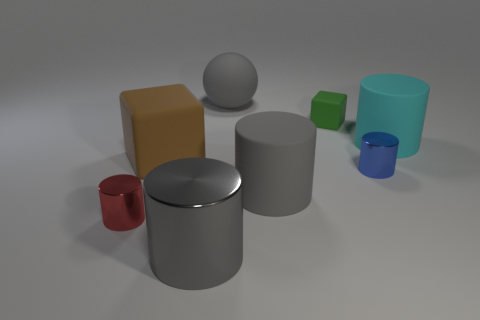Do the large ball and the large shiny cylinder have the same color?
Provide a succinct answer. Yes. There is a big thing that is behind the matte cylinder behind the block to the left of the large metallic cylinder; what is its shape?
Offer a terse response. Sphere. How big is the gray thing that is on the right side of the big ball?
Make the answer very short. Large. There is a blue metallic object that is the same size as the red cylinder; what shape is it?
Provide a succinct answer. Cylinder. What number of objects are tiny red metal cylinders or matte blocks behind the big brown thing?
Offer a very short reply. 2. There is a gray object behind the large cylinder that is behind the large brown block; what number of gray shiny cylinders are in front of it?
Provide a short and direct response. 1. The big cylinder that is the same material as the tiny red cylinder is what color?
Your response must be concise. Gray. There is a gray cylinder in front of the red shiny cylinder; does it have the same size as the ball?
Give a very brief answer. Yes. What number of objects are small red metal cylinders or big things?
Your answer should be very brief. 6. The tiny cylinder in front of the small blue cylinder that is on the right side of the cube behind the brown object is made of what material?
Provide a succinct answer. Metal. 